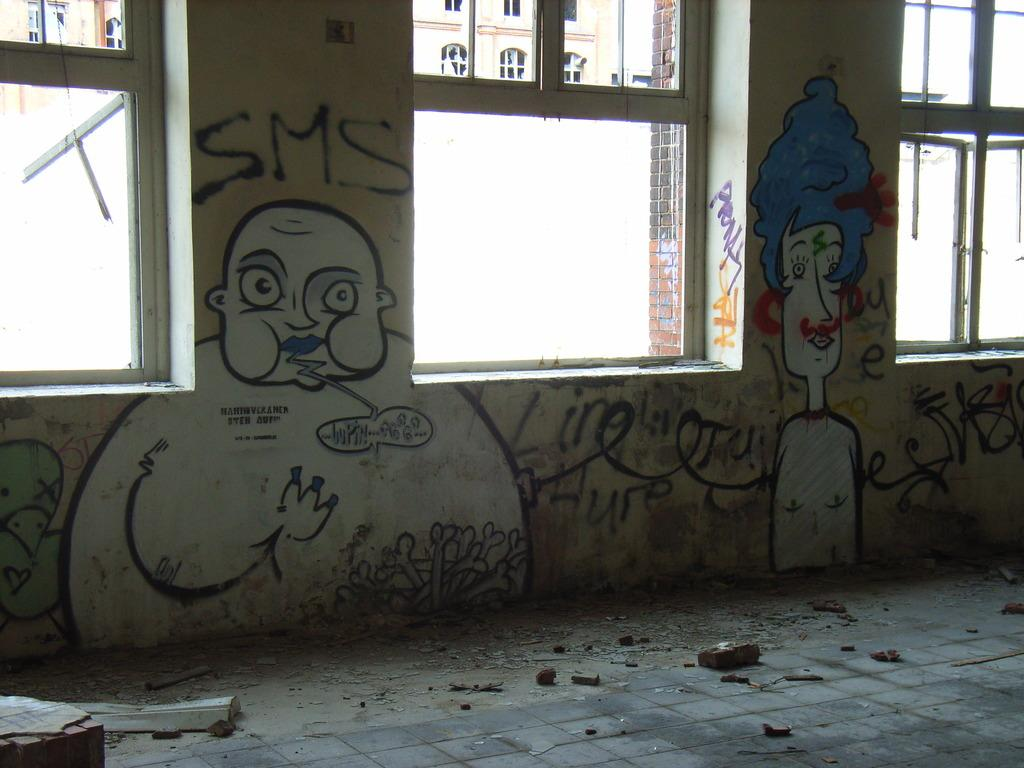What can be observed on the floor in the image? There are cracks on the floor in the image. What is present on the walls in the image? There are drawings and texts written on the walls in the image. What can be seen through the windows in the image? A building is visible through the windows in the image. What is visible on the building through the windows in the image? There are windows visible on the building through the windows in the image. What type of meeting is taking place in the image? There is no meeting present in the image; it only shows cracks on the floor, drawings and texts on the walls, and windows with a view of a building. What kind of voyage is depicted in the image? There is no voyage depicted in the image; it only shows the interior of a room with cracks on the floor, drawings and texts on the walls, and windows with a view of a building. 